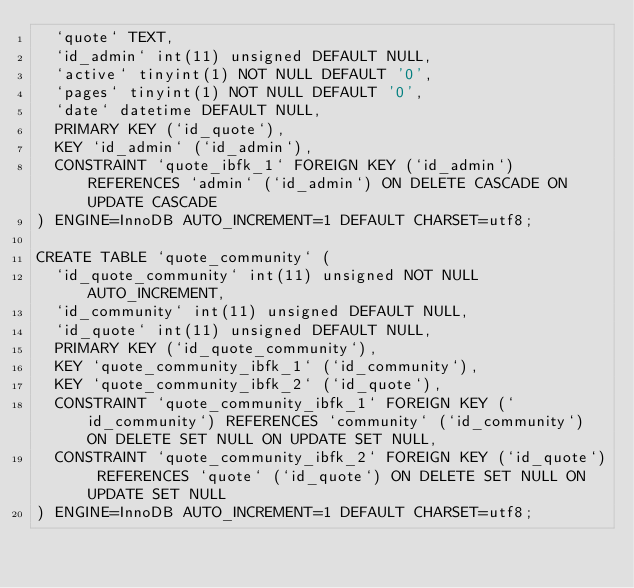Convert code to text. <code><loc_0><loc_0><loc_500><loc_500><_SQL_>  `quote` TEXT,
  `id_admin` int(11) unsigned DEFAULT NULL,
  `active` tinyint(1) NOT NULL DEFAULT '0',
  `pages` tinyint(1) NOT NULL DEFAULT '0',
  `date` datetime DEFAULT NULL,
  PRIMARY KEY (`id_quote`),
  KEY `id_admin` (`id_admin`),
  CONSTRAINT `quote_ibfk_1` FOREIGN KEY (`id_admin`) REFERENCES `admin` (`id_admin`) ON DELETE CASCADE ON UPDATE CASCADE
) ENGINE=InnoDB AUTO_INCREMENT=1 DEFAULT CHARSET=utf8;

CREATE TABLE `quote_community` (
  `id_quote_community` int(11) unsigned NOT NULL AUTO_INCREMENT,
  `id_community` int(11) unsigned DEFAULT NULL,
  `id_quote` int(11) unsigned DEFAULT NULL,
  PRIMARY KEY (`id_quote_community`),
  KEY `quote_community_ibfk_1` (`id_community`),
  KEY `quote_community_ibfk_2` (`id_quote`),
  CONSTRAINT `quote_community_ibfk_1` FOREIGN KEY (`id_community`) REFERENCES `community` (`id_community`) ON DELETE SET NULL ON UPDATE SET NULL,
  CONSTRAINT `quote_community_ibfk_2` FOREIGN KEY (`id_quote`) REFERENCES `quote` (`id_quote`) ON DELETE SET NULL ON UPDATE SET NULL
) ENGINE=InnoDB AUTO_INCREMENT=1 DEFAULT CHARSET=utf8;</code> 